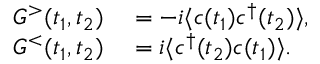<formula> <loc_0><loc_0><loc_500><loc_500>\begin{array} { r l } { G ^ { > } ( t _ { 1 } , t _ { 2 } ) } & = - i \langle c ( t _ { 1 } ) c ^ { \dagger } ( t _ { 2 } ) \rangle , } \\ { G ^ { < } ( t _ { 1 } , t _ { 2 } ) } & = i \langle c ^ { \dagger } ( t _ { 2 } ) c ( t _ { 1 } ) \rangle . } \end{array}</formula> 